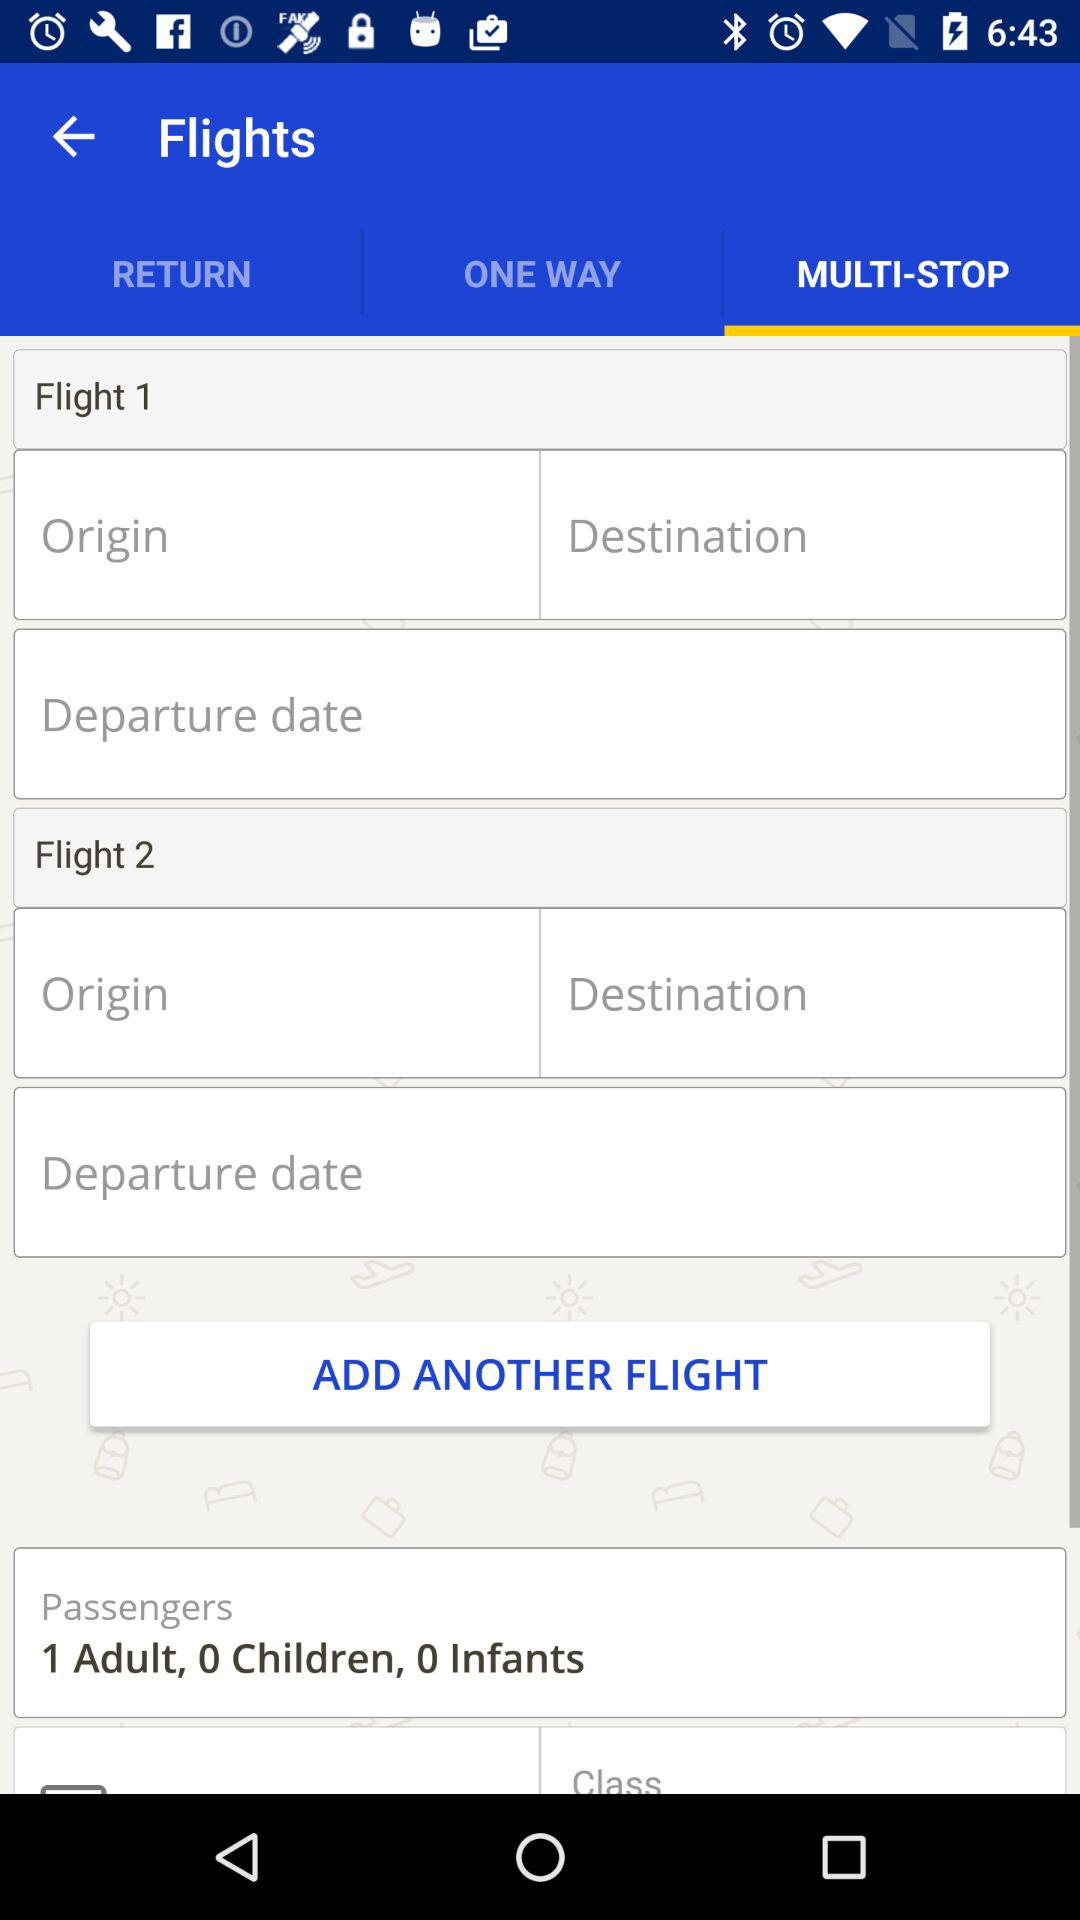How many more adults are there than children and infants?
Answer the question using a single word or phrase. 1 